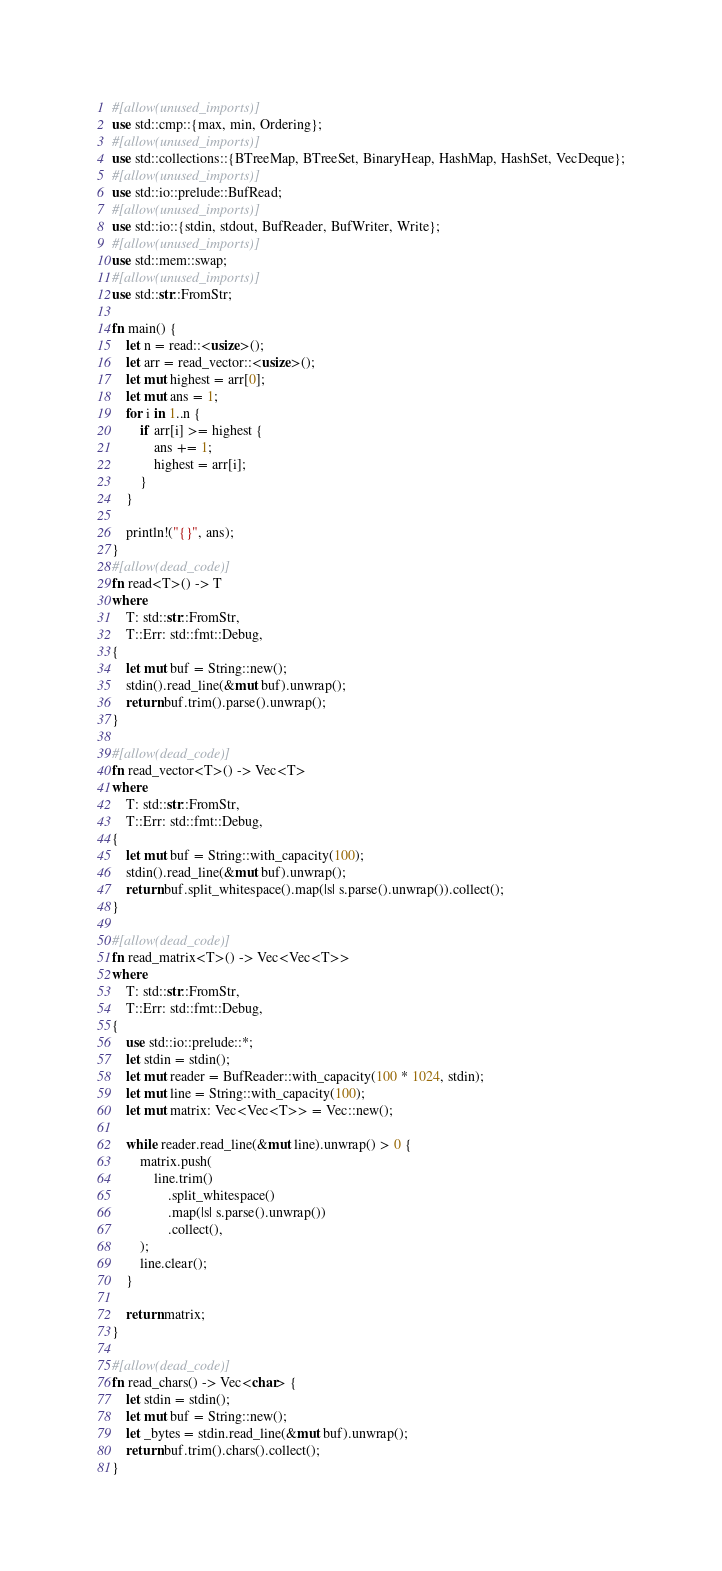<code> <loc_0><loc_0><loc_500><loc_500><_Rust_>#[allow(unused_imports)]
use std::cmp::{max, min, Ordering};
#[allow(unused_imports)]
use std::collections::{BTreeMap, BTreeSet, BinaryHeap, HashMap, HashSet, VecDeque};
#[allow(unused_imports)]
use std::io::prelude::BufRead;
#[allow(unused_imports)]
use std::io::{stdin, stdout, BufReader, BufWriter, Write};
#[allow(unused_imports)]
use std::mem::swap;
#[allow(unused_imports)]
use std::str::FromStr;

fn main() {
	let n = read::<usize>();
	let arr = read_vector::<usize>();
	let mut highest = arr[0];
	let mut ans = 1;
	for i in 1..n {
		if arr[i] >= highest {
			ans += 1;
			highest = arr[i];
		}
	}
	
	println!("{}", ans);
}
#[allow(dead_code)]
fn read<T>() -> T
where
    T: std::str::FromStr,
    T::Err: std::fmt::Debug,
{
    let mut buf = String::new();
    stdin().read_line(&mut buf).unwrap();
    return buf.trim().parse().unwrap();
}

#[allow(dead_code)]
fn read_vector<T>() -> Vec<T>
where
    T: std::str::FromStr,
    T::Err: std::fmt::Debug,
{
    let mut buf = String::with_capacity(100);
    stdin().read_line(&mut buf).unwrap();
    return buf.split_whitespace().map(|s| s.parse().unwrap()).collect();
}

#[allow(dead_code)]
fn read_matrix<T>() -> Vec<Vec<T>>
where
    T: std::str::FromStr,
    T::Err: std::fmt::Debug,
{
    use std::io::prelude::*;
    let stdin = stdin();
    let mut reader = BufReader::with_capacity(100 * 1024, stdin);
    let mut line = String::with_capacity(100);
    let mut matrix: Vec<Vec<T>> = Vec::new();

    while reader.read_line(&mut line).unwrap() > 0 {
        matrix.push(
            line.trim()
                .split_whitespace()
                .map(|s| s.parse().unwrap())
                .collect(),
        );
        line.clear();
    }

    return matrix;
}

#[allow(dead_code)]
fn read_chars() -> Vec<char> {
    let stdin = stdin();
    let mut buf = String::new();
    let _bytes = stdin.read_line(&mut buf).unwrap();
    return buf.trim().chars().collect();
}
</code> 